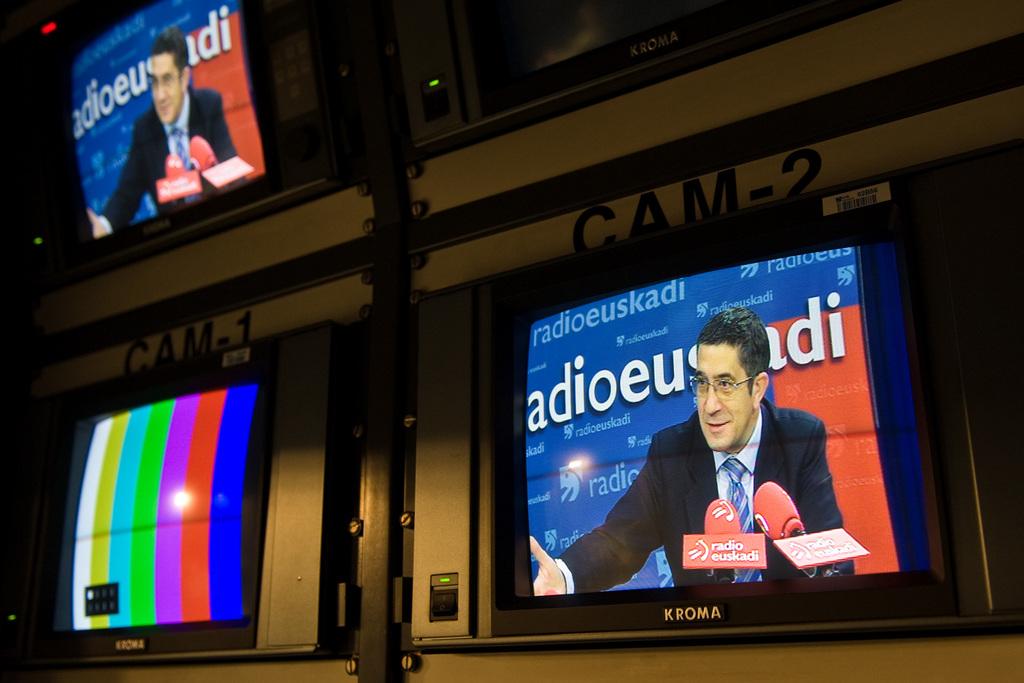What are the names of the two cameras on the bottom?
Make the answer very short. Cam-1 cam-2. 